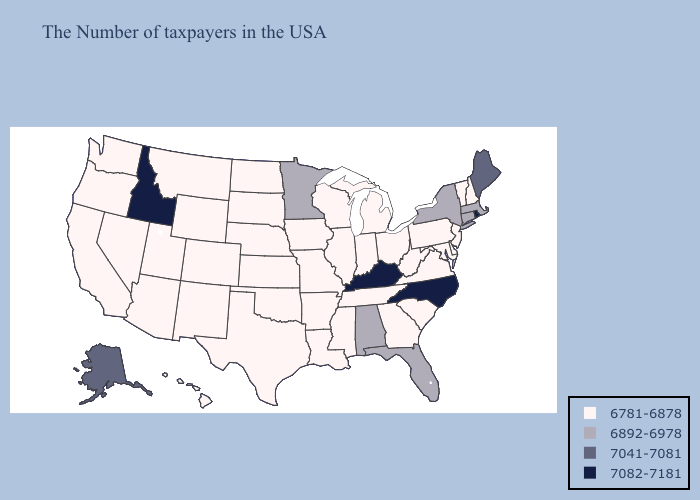Does Missouri have the lowest value in the USA?
Give a very brief answer. Yes. Does Michigan have a lower value than North Dakota?
Be succinct. No. Does Alabama have the same value as Arizona?
Short answer required. No. Does North Carolina have the highest value in the USA?
Write a very short answer. Yes. Does New Jersey have the same value as New York?
Concise answer only. No. Does the first symbol in the legend represent the smallest category?
Be succinct. Yes. Does Florida have a lower value than Rhode Island?
Concise answer only. Yes. Which states have the highest value in the USA?
Write a very short answer. Rhode Island, North Carolina, Kentucky, Idaho. What is the value of Kansas?
Quick response, please. 6781-6878. Which states have the lowest value in the West?
Be succinct. Wyoming, Colorado, New Mexico, Utah, Montana, Arizona, Nevada, California, Washington, Oregon, Hawaii. Does Connecticut have the lowest value in the USA?
Give a very brief answer. No. What is the value of Idaho?
Be succinct. 7082-7181. Which states have the lowest value in the MidWest?
Give a very brief answer. Ohio, Michigan, Indiana, Wisconsin, Illinois, Missouri, Iowa, Kansas, Nebraska, South Dakota, North Dakota. Does the first symbol in the legend represent the smallest category?
Concise answer only. Yes. 